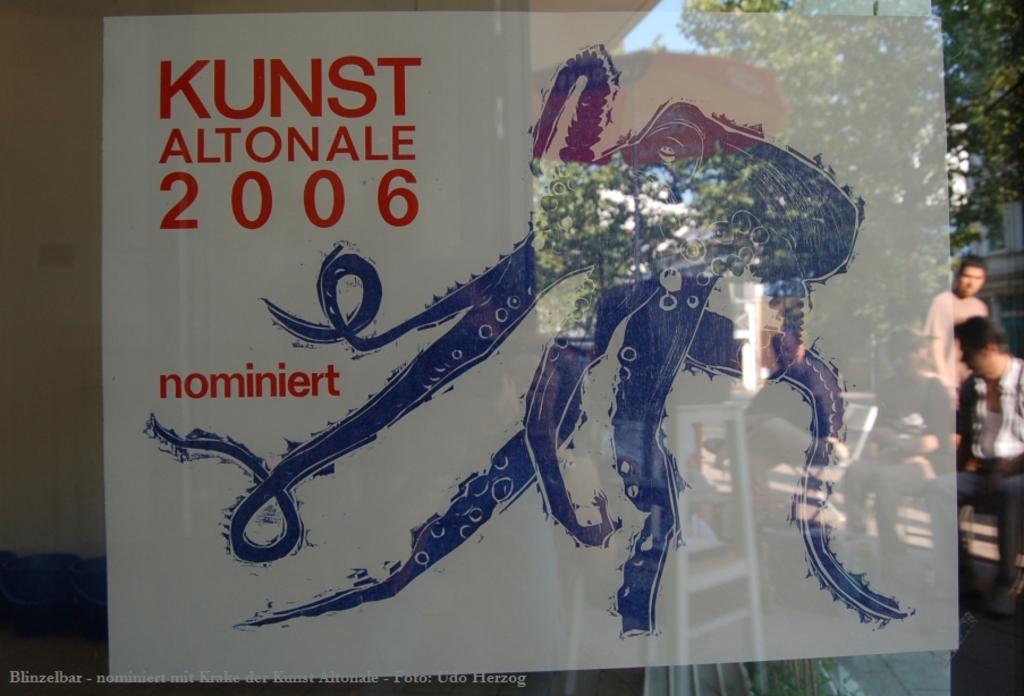What year is this?
Provide a short and direct response. 2006. 